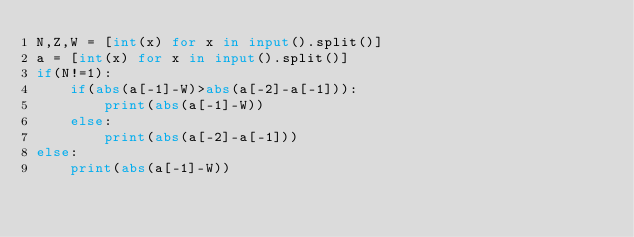<code> <loc_0><loc_0><loc_500><loc_500><_Python_>N,Z,W = [int(x) for x in input().split()]
a = [int(x) for x in input().split()]
if(N!=1):
    if(abs(a[-1]-W)>abs(a[-2]-a[-1])):
        print(abs(a[-1]-W))
    else:
        print(abs(a[-2]-a[-1]))
else:
    print(abs(a[-1]-W))
</code> 